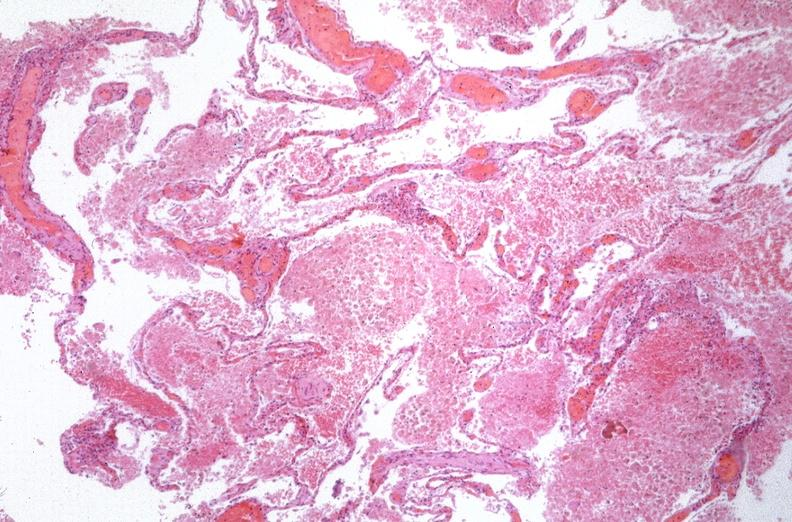what is present?
Answer the question using a single word or phrase. Respiratory 